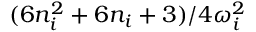<formula> <loc_0><loc_0><loc_500><loc_500>{ ( 6 n _ { i } ^ { 2 } + 6 n _ { i } + 3 ) } / { 4 \omega _ { i } ^ { 2 } }</formula> 